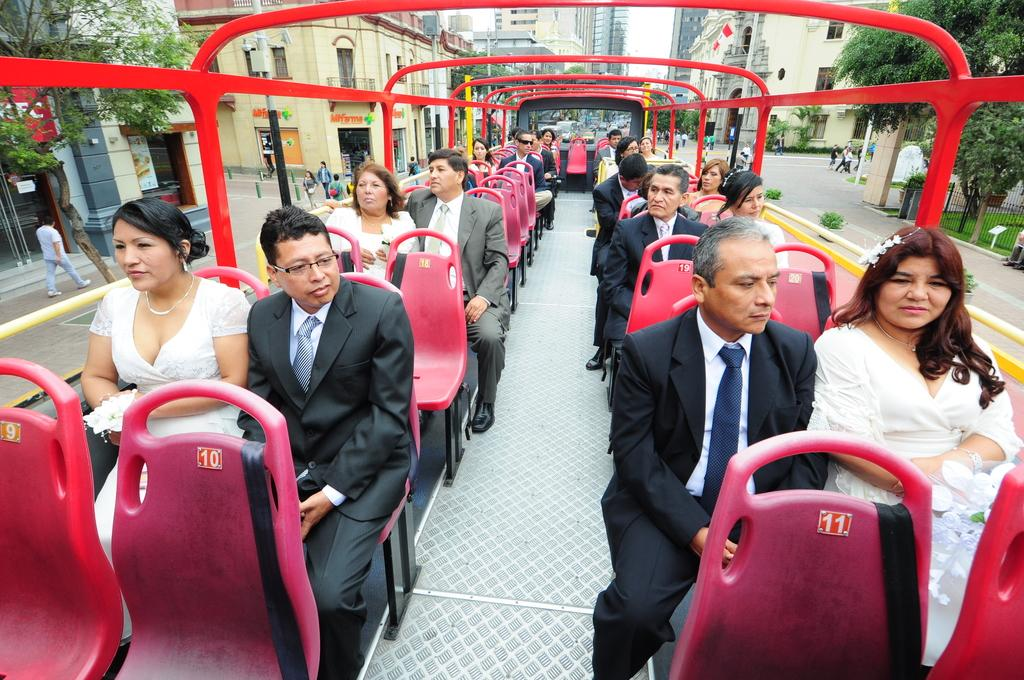<image>
Share a concise interpretation of the image provided. A group of people dressed for a wedding are sitting in an open top bus and seat numbers 9, 10, and 11 are empty. 